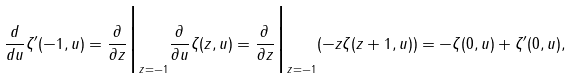<formula> <loc_0><loc_0><loc_500><loc_500>\frac { d } { d u } \zeta ^ { \prime } ( - 1 , u ) = \frac { \partial } { \partial z } \Big { | } _ { z = - 1 } \frac { \partial } { \partial u } \zeta ( z , u ) = \frac { \partial } { \partial z } \Big { | } _ { z = - 1 } ( - z \zeta ( z + 1 , u ) ) = - \zeta ( 0 , u ) + \zeta ^ { \prime } ( 0 , u ) ,</formula> 